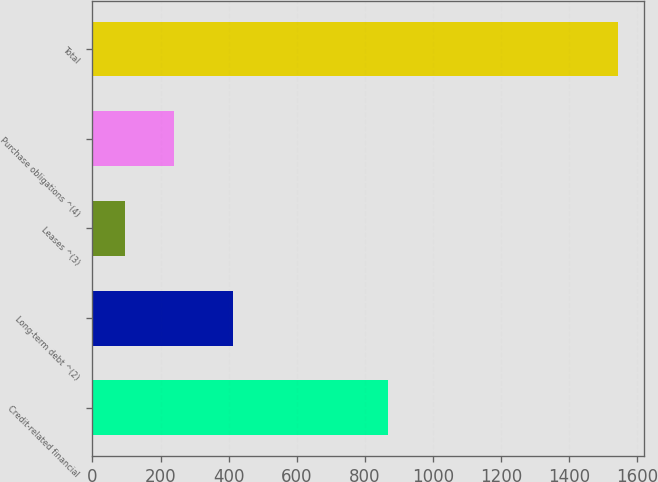<chart> <loc_0><loc_0><loc_500><loc_500><bar_chart><fcel>Credit-related financial<fcel>Long-term debt ^(2)<fcel>Leases ^(3)<fcel>Purchase obligations ^(4)<fcel>Total<nl><fcel>868<fcel>414<fcel>95<fcel>239.7<fcel>1542<nl></chart> 